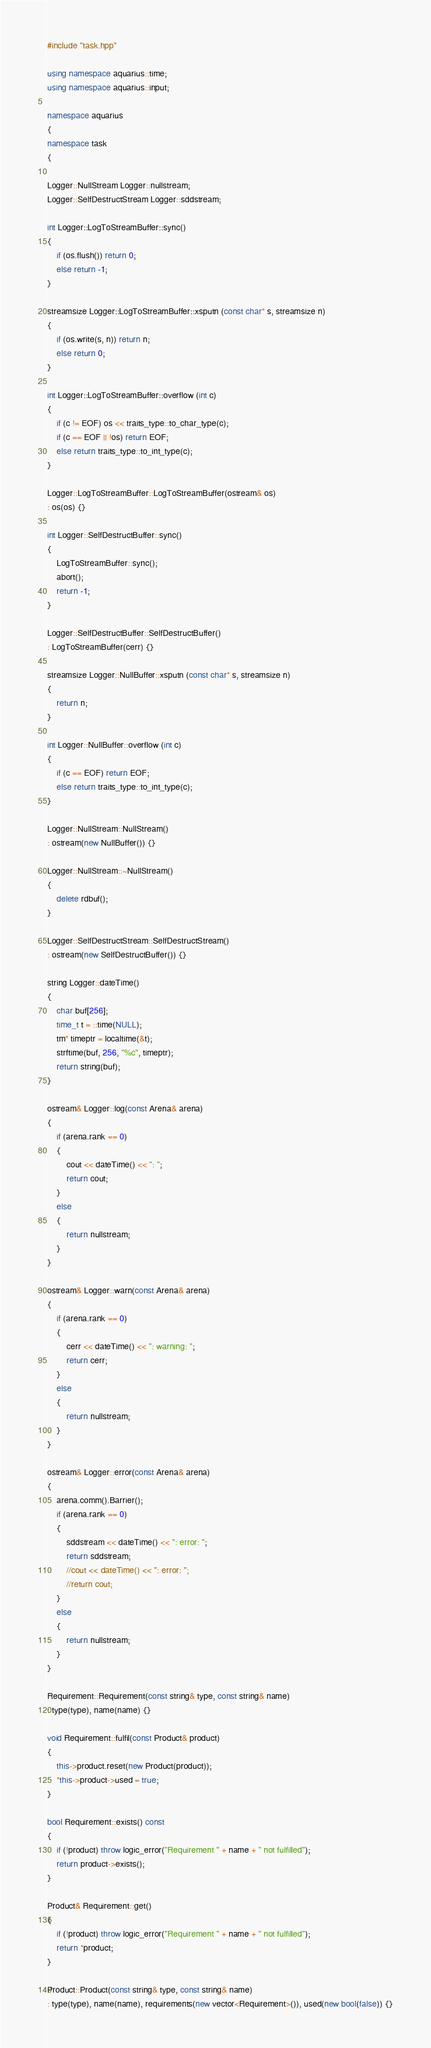Convert code to text. <code><loc_0><loc_0><loc_500><loc_500><_C++_>#include "task.hpp"

using namespace aquarius::time;
using namespace aquarius::input;

namespace aquarius
{
namespace task
{

Logger::NullStream Logger::nullstream;
Logger::SelfDestructStream Logger::sddstream;

int Logger::LogToStreamBuffer::sync()
{
    if (os.flush()) return 0;
    else return -1;
}

streamsize Logger::LogToStreamBuffer::xsputn (const char* s, streamsize n)
{
    if (os.write(s, n)) return n;
    else return 0;
}

int Logger::LogToStreamBuffer::overflow (int c)
{
    if (c != EOF) os << traits_type::to_char_type(c);
    if (c == EOF || !os) return EOF;
    else return traits_type::to_int_type(c);
}

Logger::LogToStreamBuffer::LogToStreamBuffer(ostream& os)
: os(os) {}

int Logger::SelfDestructBuffer::sync()
{
    LogToStreamBuffer::sync();
    abort();
    return -1;
}

Logger::SelfDestructBuffer::SelfDestructBuffer()
: LogToStreamBuffer(cerr) {}

streamsize Logger::NullBuffer::xsputn (const char* s, streamsize n)
{
    return n;
}

int Logger::NullBuffer::overflow (int c)
{
    if (c == EOF) return EOF;
    else return traits_type::to_int_type(c);
}

Logger::NullStream::NullStream()
: ostream(new NullBuffer()) {}

Logger::NullStream::~NullStream()
{
    delete rdbuf();
}

Logger::SelfDestructStream::SelfDestructStream()
: ostream(new SelfDestructBuffer()) {}

string Logger::dateTime()
{
    char buf[256];
    time_t t = ::time(NULL);
    tm* timeptr = localtime(&t);
    strftime(buf, 256, "%c", timeptr);
    return string(buf);
}

ostream& Logger::log(const Arena& arena)
{
    if (arena.rank == 0)
    {
        cout << dateTime() << ": ";
        return cout;
    }
    else
    {
        return nullstream;
    }
}

ostream& Logger::warn(const Arena& arena)
{
    if (arena.rank == 0)
    {
        cerr << dateTime() << ": warning: ";
        return cerr;
    }
    else
    {
        return nullstream;
    }
}

ostream& Logger::error(const Arena& arena)
{
    arena.comm().Barrier();
    if (arena.rank == 0)
    {
        sddstream << dateTime() << ": error: ";
        return sddstream;
        //cout << dateTime() << ": error: ";
        //return cout;
    }
    else
    {
        return nullstream;
    }
}

Requirement::Requirement(const string& type, const string& name)
: type(type), name(name) {}

void Requirement::fulfil(const Product& product)
{
    this->product.reset(new Product(product));
    *this->product->used = true;
}

bool Requirement::exists() const
{
    if (!product) throw logic_error("Requirement " + name + " not fulfilled");
    return product->exists();
}

Product& Requirement::get()
{
    if (!product) throw logic_error("Requirement " + name + " not fulfilled");
    return *product;
}

Product::Product(const string& type, const string& name)
: type(type), name(name), requirements(new vector<Requirement>()), used(new bool(false)) {}
</code> 